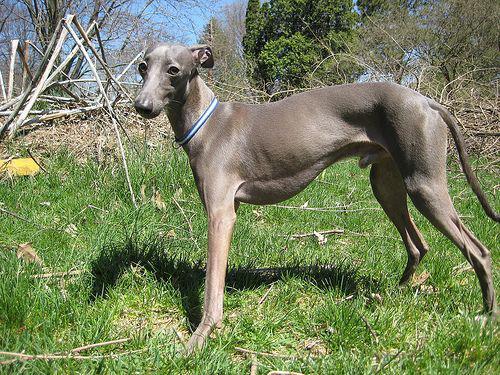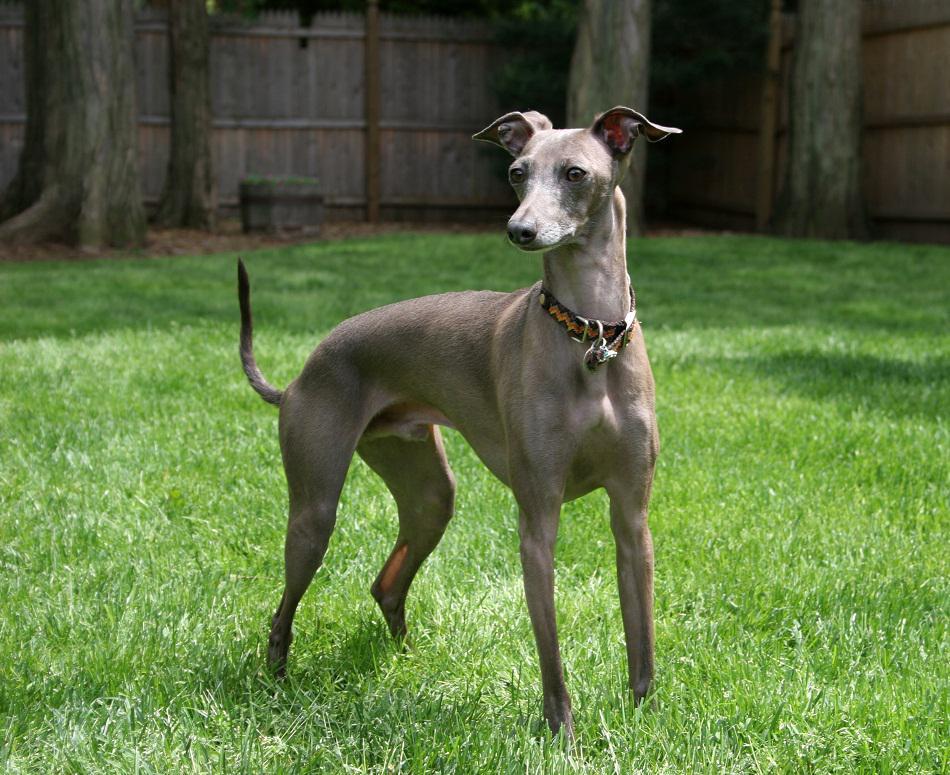The first image is the image on the left, the second image is the image on the right. Evaluate the accuracy of this statement regarding the images: "In both images the dogs are on the grass.". Is it true? Answer yes or no. Yes. The first image is the image on the left, the second image is the image on the right. Considering the images on both sides, is "There is one dog with a red collar around its neck." valid? Answer yes or no. No. 